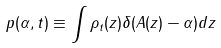Convert formula to latex. <formula><loc_0><loc_0><loc_500><loc_500>p ( \alpha , t ) \equiv \int \rho _ { t } ( z ) \delta ( A ( z ) - \alpha ) d z</formula> 